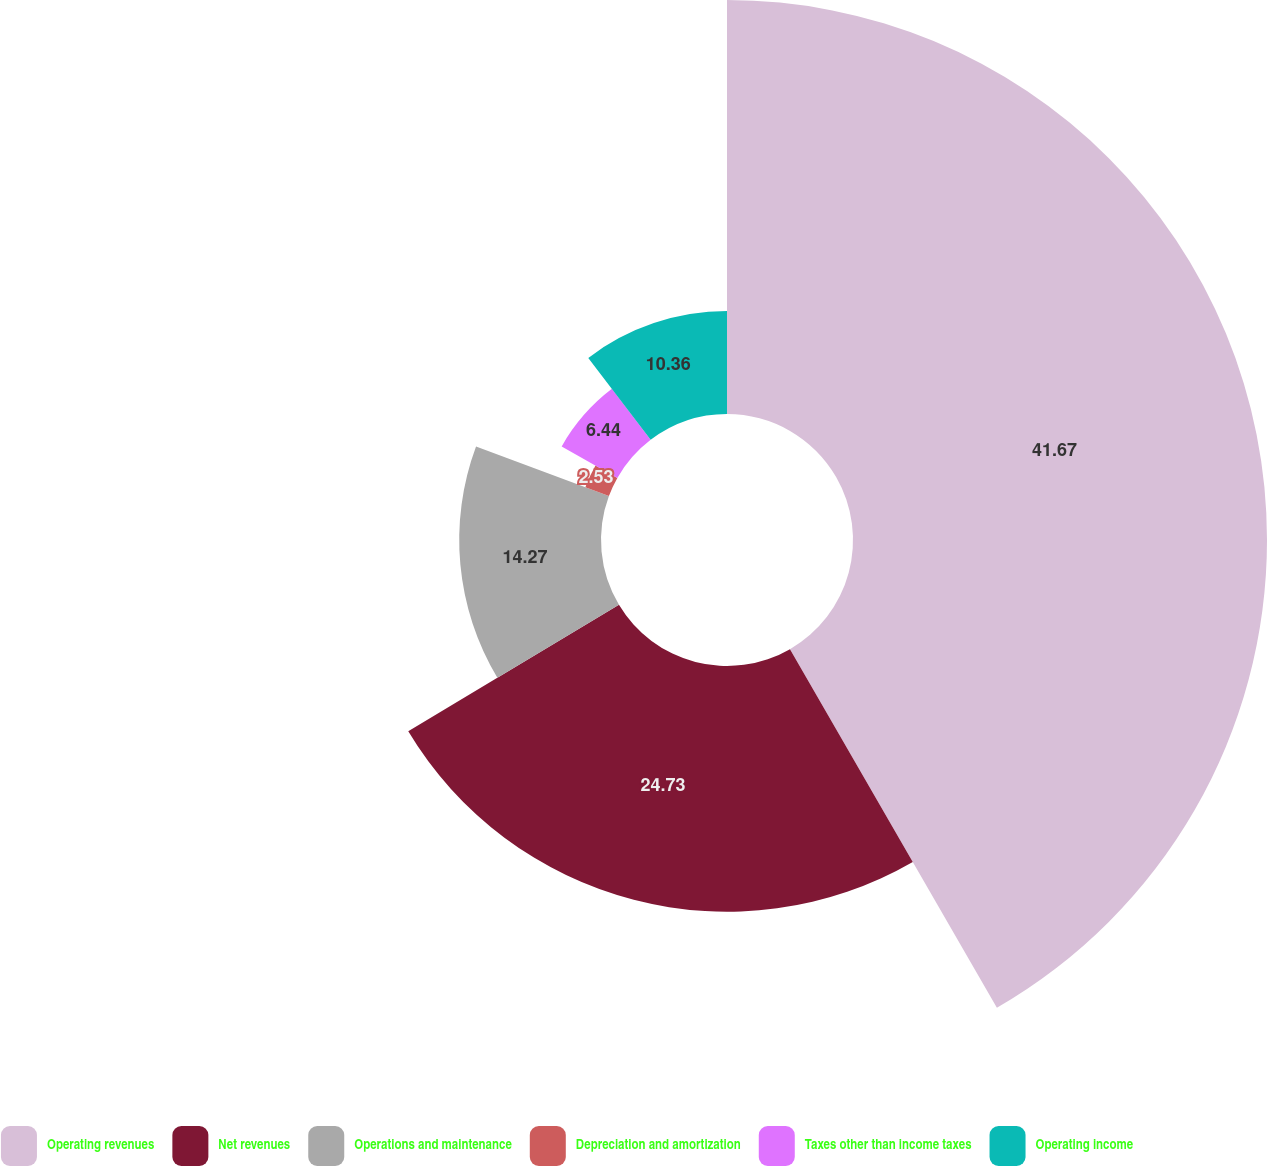Convert chart. <chart><loc_0><loc_0><loc_500><loc_500><pie_chart><fcel>Operating revenues<fcel>Net revenues<fcel>Operations and maintenance<fcel>Depreciation and amortization<fcel>Taxes other than income taxes<fcel>Operating income<nl><fcel>41.67%<fcel>24.73%<fcel>14.27%<fcel>2.53%<fcel>6.44%<fcel>10.36%<nl></chart> 